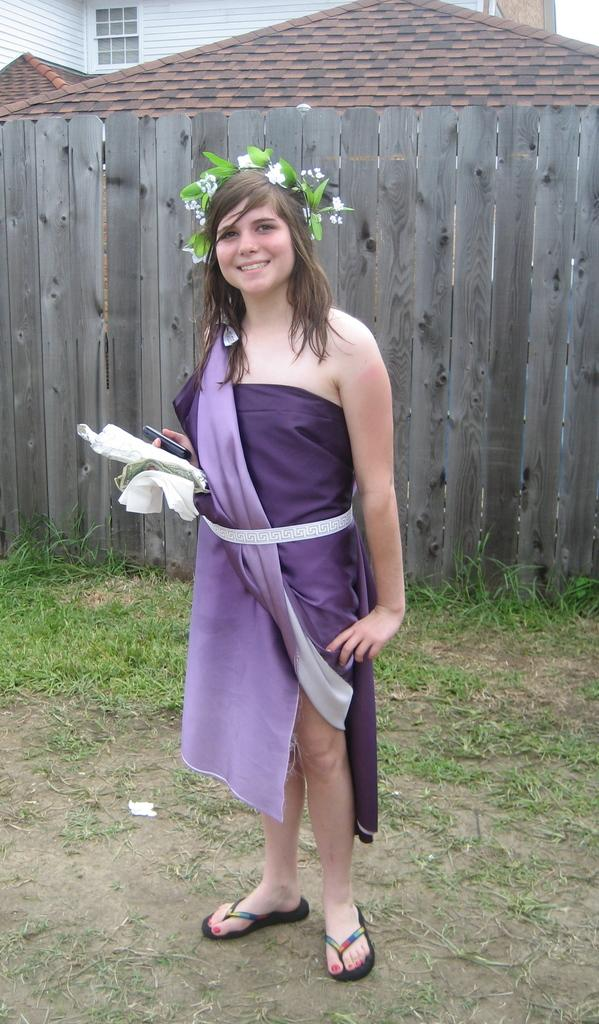What is the person in the image doing? The person is standing in the image. What is the person holding in the image? The person is holding something. What can be seen on the person's head in the image? The person is wearing a crown. What can be seen in the background of the image? There is fencing, houses, windows, and green grass visible in the background. What type of war is being fought in the image? There is no war present in the image; it features a person standing with a crown and various background elements. What fact can be determined about the person's hair in the image? There is no information about the person's hair in the image, as it is not mentioned in the provided facts. 